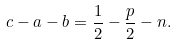<formula> <loc_0><loc_0><loc_500><loc_500>c - a - b = \frac { 1 } { 2 } - \frac { p } { 2 } - n .</formula> 